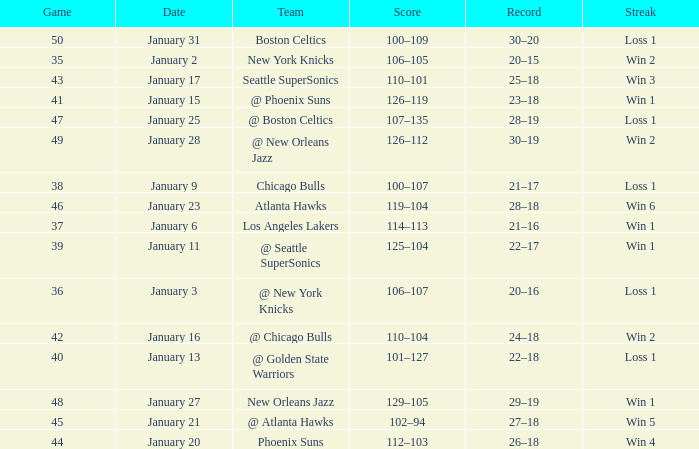What is the Team in Game 41? @ Phoenix Suns. 